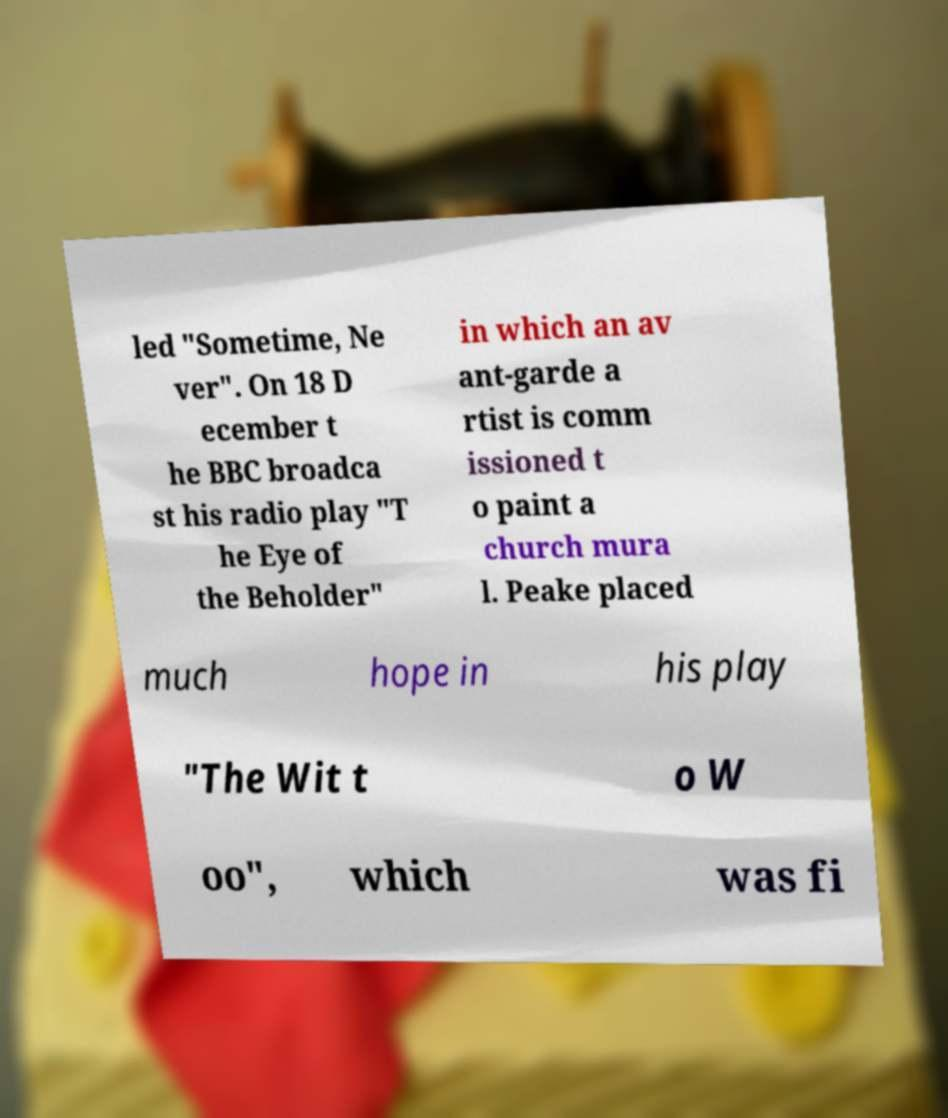Could you assist in decoding the text presented in this image and type it out clearly? led "Sometime, Ne ver". On 18 D ecember t he BBC broadca st his radio play "T he Eye of the Beholder" in which an av ant-garde a rtist is comm issioned t o paint a church mura l. Peake placed much hope in his play "The Wit t o W oo", which was fi 